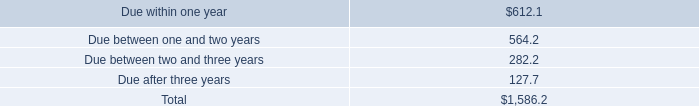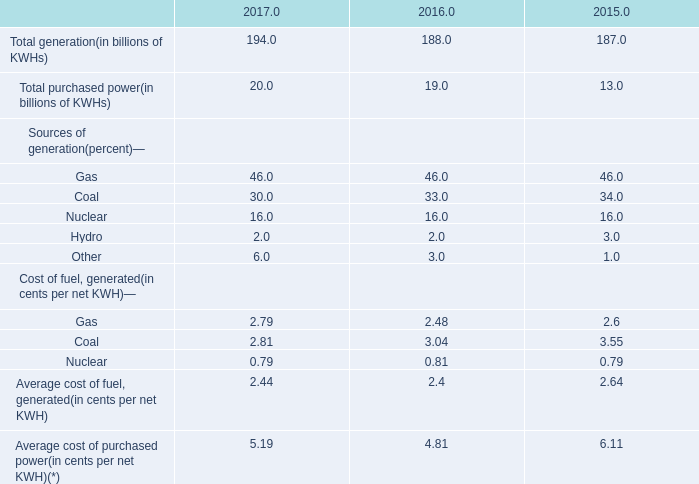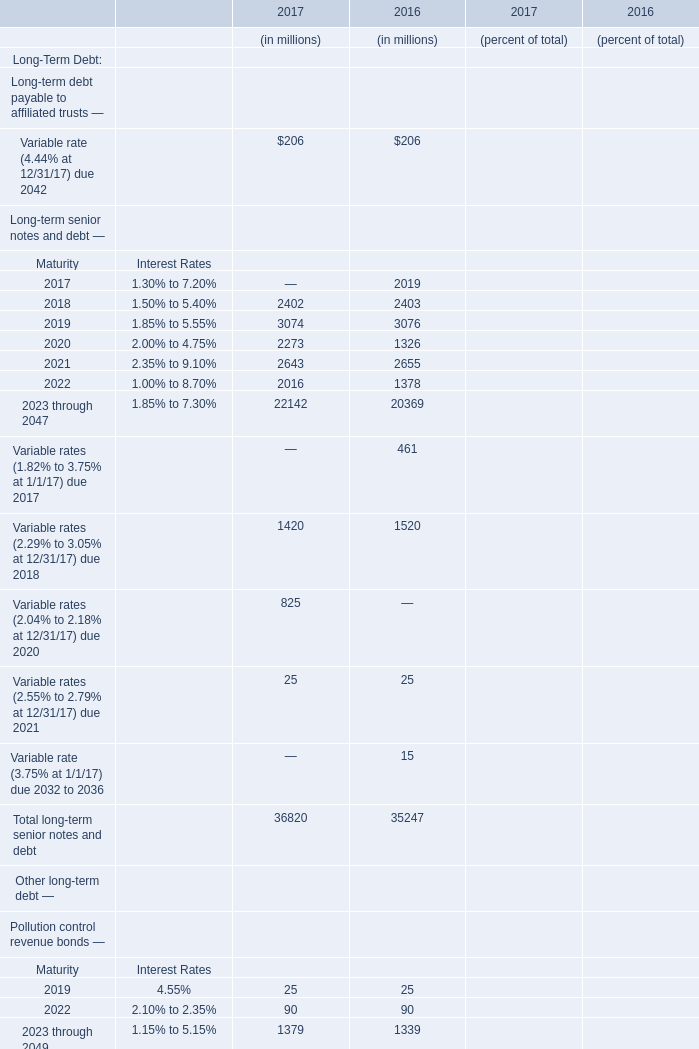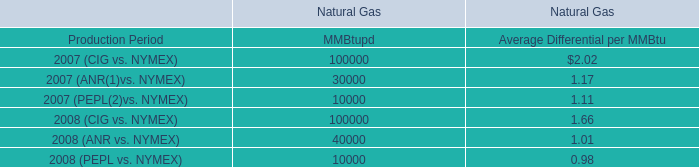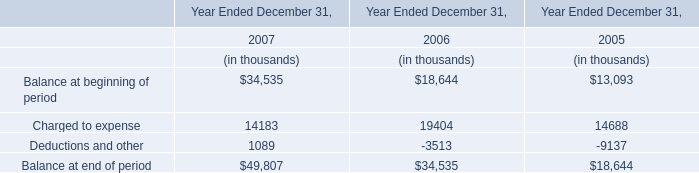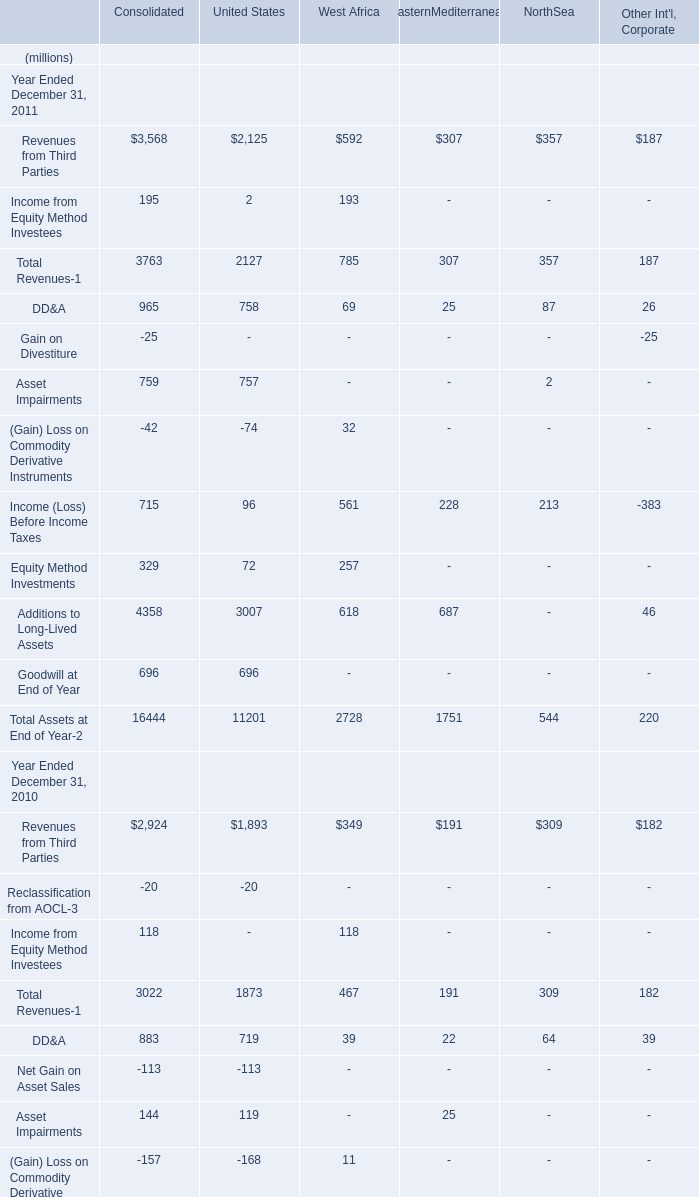As As the chart 2 shows,which year is the value of Total long-term senior notes and debt the highest? 
Answer: 2017. 